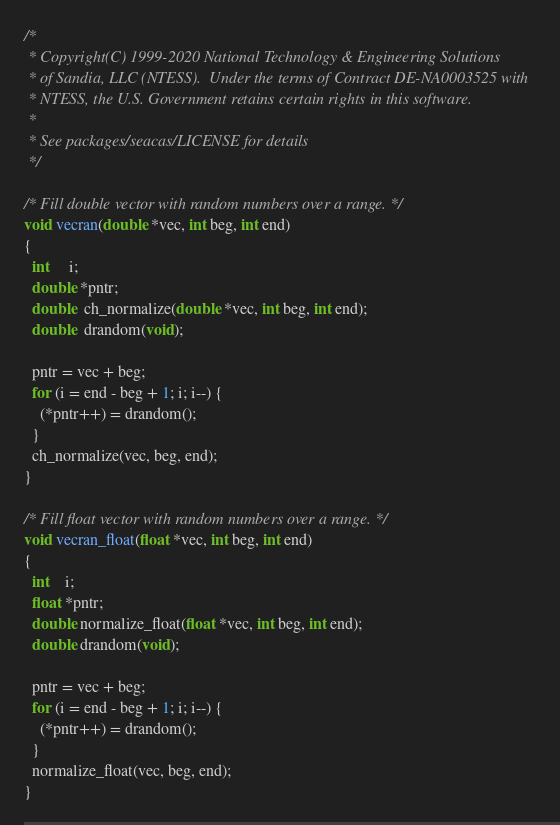<code> <loc_0><loc_0><loc_500><loc_500><_C_>/*
 * Copyright(C) 1999-2020 National Technology & Engineering Solutions
 * of Sandia, LLC (NTESS).  Under the terms of Contract DE-NA0003525 with
 * NTESS, the U.S. Government retains certain rights in this software.
 *
 * See packages/seacas/LICENSE for details
 */

/* Fill double vector with random numbers over a range. */
void vecran(double *vec, int beg, int end)
{
  int     i;
  double *pntr;
  double  ch_normalize(double *vec, int beg, int end);
  double  drandom(void);

  pntr = vec + beg;
  for (i = end - beg + 1; i; i--) {
    (*pntr++) = drandom();
  }
  ch_normalize(vec, beg, end);
}

/* Fill float vector with random numbers over a range. */
void vecran_float(float *vec, int beg, int end)
{
  int    i;
  float *pntr;
  double normalize_float(float *vec, int beg, int end);
  double drandom(void);

  pntr = vec + beg;
  for (i = end - beg + 1; i; i--) {
    (*pntr++) = drandom();
  }
  normalize_float(vec, beg, end);
}
</code> 